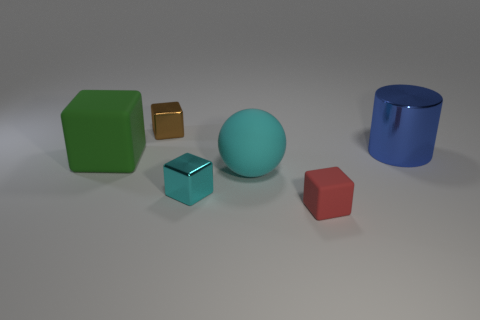How many things are in front of the large blue thing?
Provide a short and direct response. 4. Are there more big objects in front of the blue metallic cylinder than big blue cylinders?
Your answer should be compact. Yes. What shape is the small red object that is the same material as the cyan ball?
Give a very brief answer. Cube. The block to the left of the shiny cube on the left side of the tiny cyan metallic block is what color?
Provide a short and direct response. Green. Is the green thing the same shape as the large blue shiny object?
Your answer should be compact. No. There is another cyan object that is the same shape as the tiny matte thing; what is its material?
Give a very brief answer. Metal. Is there a blue object in front of the metal block behind the large rubber thing to the right of the tiny cyan shiny cube?
Provide a succinct answer. Yes. There is a red object; does it have the same shape as the cyan object that is behind the tiny cyan shiny cube?
Give a very brief answer. No. Is there anything else of the same color as the ball?
Ensure brevity in your answer.  Yes. There is a metal object in front of the big green block; does it have the same color as the large rubber thing on the right side of the brown thing?
Provide a short and direct response. Yes. 